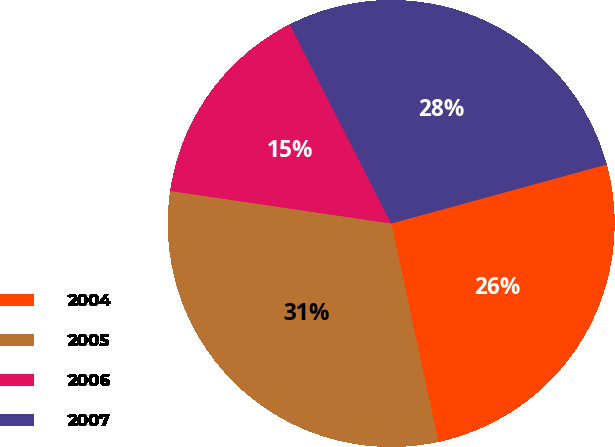Convert chart to OTSL. <chart><loc_0><loc_0><loc_500><loc_500><pie_chart><fcel>2004<fcel>2005<fcel>2006<fcel>2007<nl><fcel>25.88%<fcel>30.71%<fcel>15.17%<fcel>28.25%<nl></chart> 